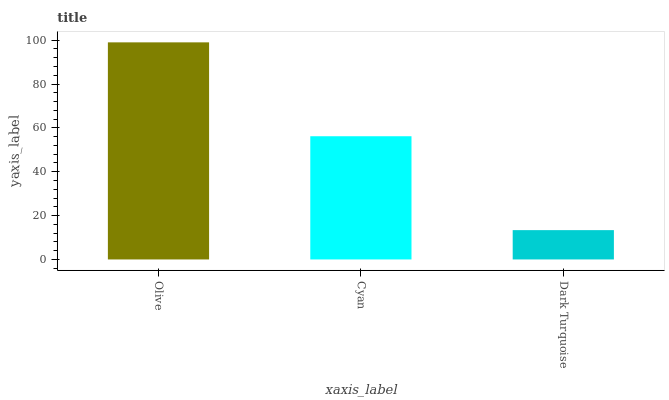Is Dark Turquoise the minimum?
Answer yes or no. Yes. Is Olive the maximum?
Answer yes or no. Yes. Is Cyan the minimum?
Answer yes or no. No. Is Cyan the maximum?
Answer yes or no. No. Is Olive greater than Cyan?
Answer yes or no. Yes. Is Cyan less than Olive?
Answer yes or no. Yes. Is Cyan greater than Olive?
Answer yes or no. No. Is Olive less than Cyan?
Answer yes or no. No. Is Cyan the high median?
Answer yes or no. Yes. Is Cyan the low median?
Answer yes or no. Yes. Is Olive the high median?
Answer yes or no. No. Is Olive the low median?
Answer yes or no. No. 